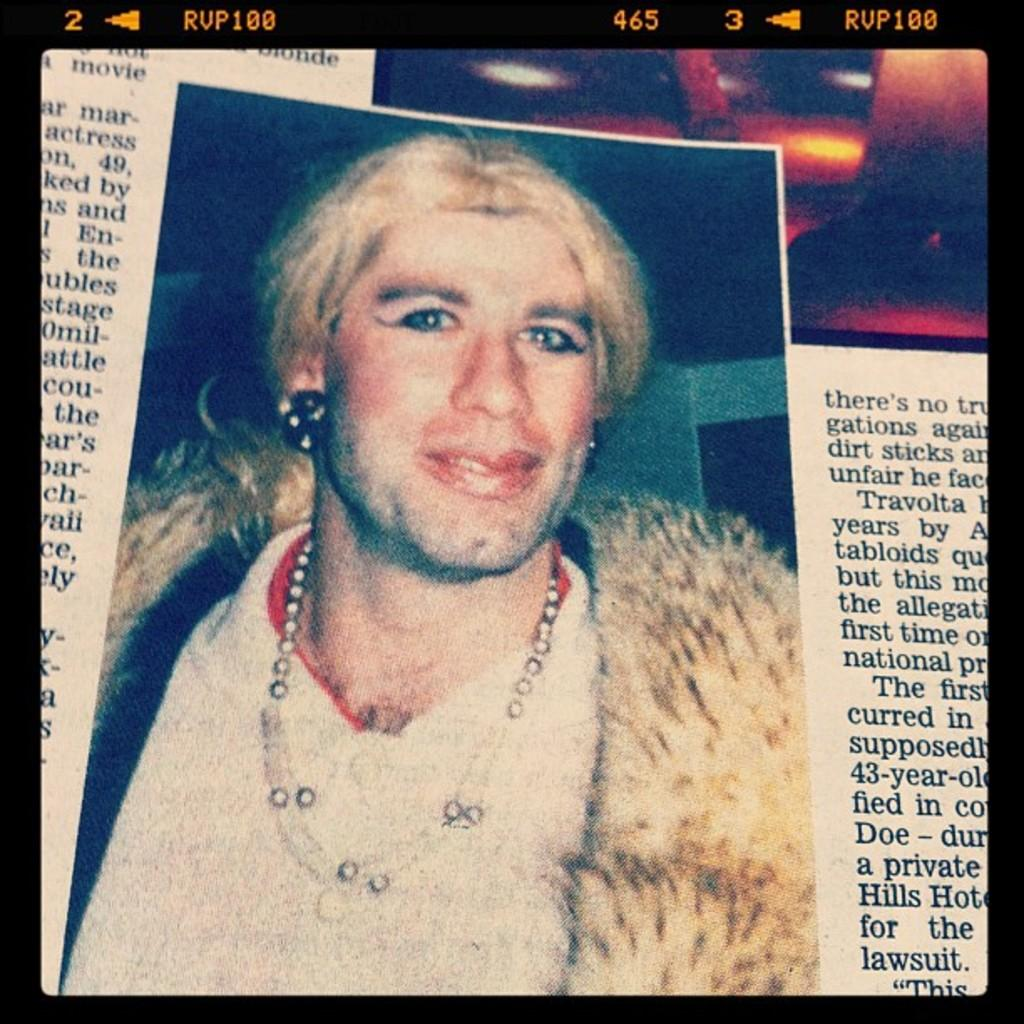What is the main subject of the image? The image is of a newspaper. What can be seen in the picture within the newspaper? There is a picture of a man in the newspaper. What is the man wearing in the picture? The man is wearing a white t-shirt in the picture. Can you describe the text on the newspaper? There is text on both the left and right sides of the newspaper. What event led to the man being enslaved in the image? There is no mention of slavery or any event related to it in the image. The image only shows a picture of a man wearing a white t-shirt in a newspaper. 